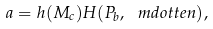<formula> <loc_0><loc_0><loc_500><loc_500>a = h ( M _ { c } ) H ( P _ { b } , \ m d o t t e n ) ,</formula> 